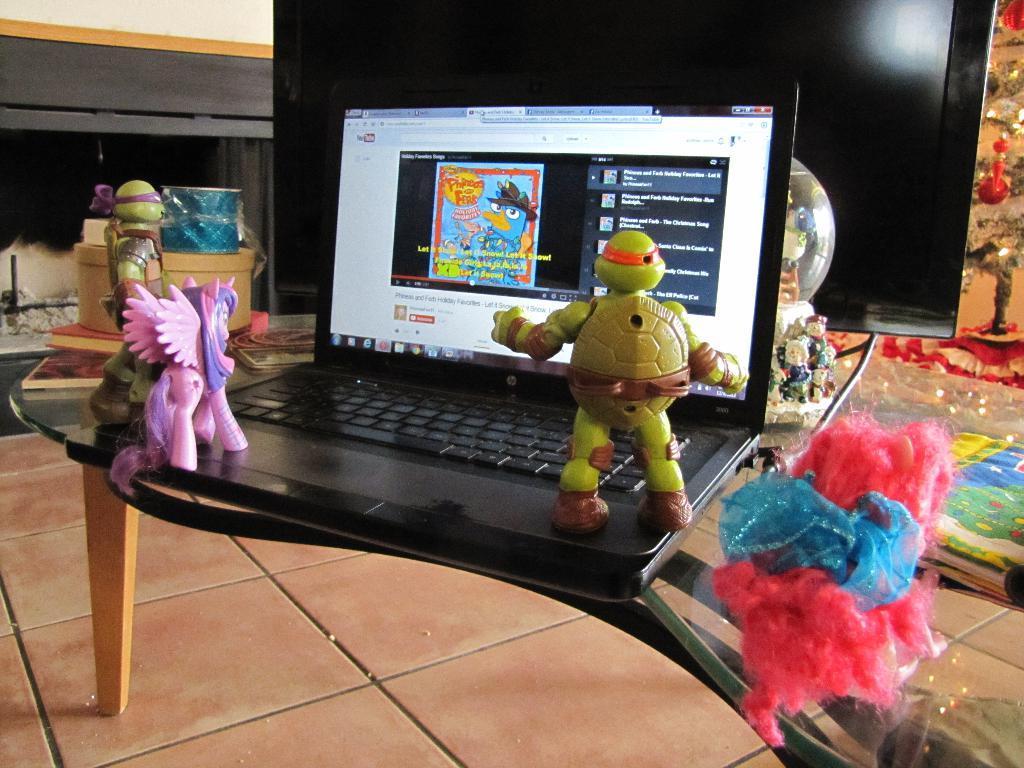Describe this image in one or two sentences. There is a table in the given picture on which a laptop is placed in front of a TV. There are some toys placed on the laptop. 